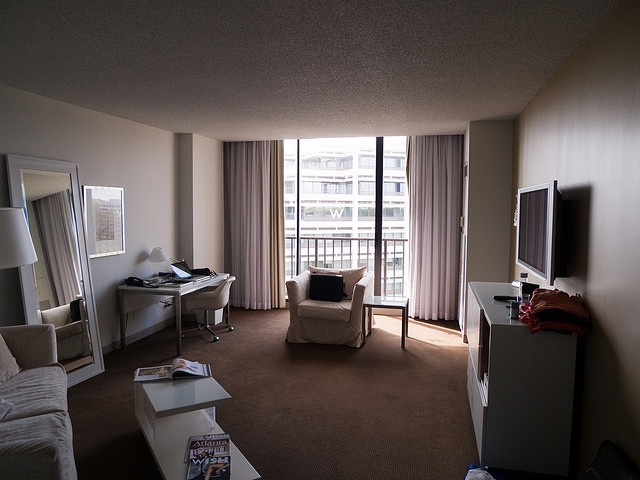Describe the objects in this image and their specific colors. I can see couch in black and gray tones, chair in black, gray, and lightgray tones, couch in black, gray, and lightgray tones, tv in black, lightgray, gray, and darkgray tones, and handbag in black, maroon, brown, and gray tones in this image. 